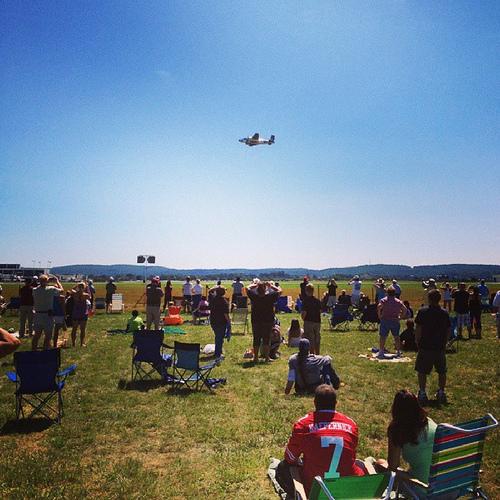Describe the attire of the people in the crowd. The people in the crowd are dressed casually, likely for a warm day, with many wearing shorts, t-shirts, and hats to protect themselves from the sun. What might be the reason for the gathering of people? The gathering is probably for an air show or a similar event where spectators are watching aerial displays or performances by aircrafts. Imagine an interesting story featuring a child attending this event. A young child named sharegpt4v/sam eagerly awaited this day for months. As sharegpt4v/sam arrived at the air show with his family, his eyes lit up with excitement. He had always dreamt of seeing planes up close and this was his chance. They found a spot on the grassy field where they could see the runway clearly. sharegpt4v/sam sat on his small blue chair, barely able to contain his enthusiasm. The sound of engines roared through the sky as the first plane soared above them. sharegpt4v/sam's mouth opened in awe as he watched the stunts and heard the thrilling buzz of the aircrafts. This was a day he would never forget, filled with awe, inspiration, and dreams of becoming a pilot someday. 